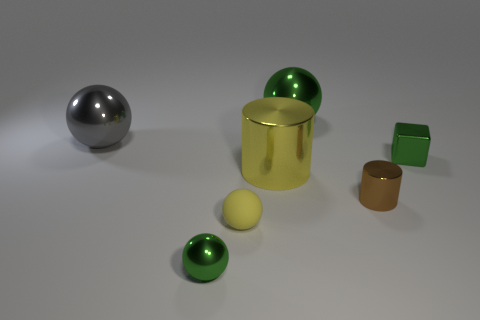Is there a small shiny cube of the same color as the rubber ball?
Provide a short and direct response. No. How many other things are the same shape as the big green shiny thing?
Your answer should be compact. 3. What shape is the green thing in front of the tiny brown metallic object?
Ensure brevity in your answer.  Sphere. Does the big gray thing have the same shape as the small green metallic thing that is to the right of the tiny metallic ball?
Offer a very short reply. No. How big is the metallic sphere that is left of the small matte object and behind the brown metallic cylinder?
Offer a very short reply. Large. What is the color of the object that is both behind the small brown shiny thing and in front of the metal cube?
Give a very brief answer. Yellow. Are there any other things that have the same material as the big gray sphere?
Give a very brief answer. Yes. Are there fewer brown metallic things in front of the brown thing than tiny yellow rubber spheres behind the small metallic cube?
Ensure brevity in your answer.  No. Is there any other thing that has the same color as the tiny matte sphere?
Make the answer very short. Yes. The big gray thing has what shape?
Keep it short and to the point. Sphere. 